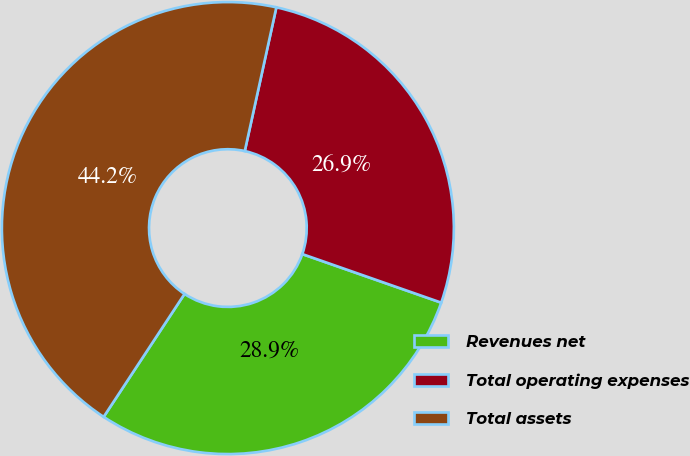Convert chart. <chart><loc_0><loc_0><loc_500><loc_500><pie_chart><fcel>Revenues net<fcel>Total operating expenses<fcel>Total assets<nl><fcel>28.91%<fcel>26.91%<fcel>44.18%<nl></chart> 